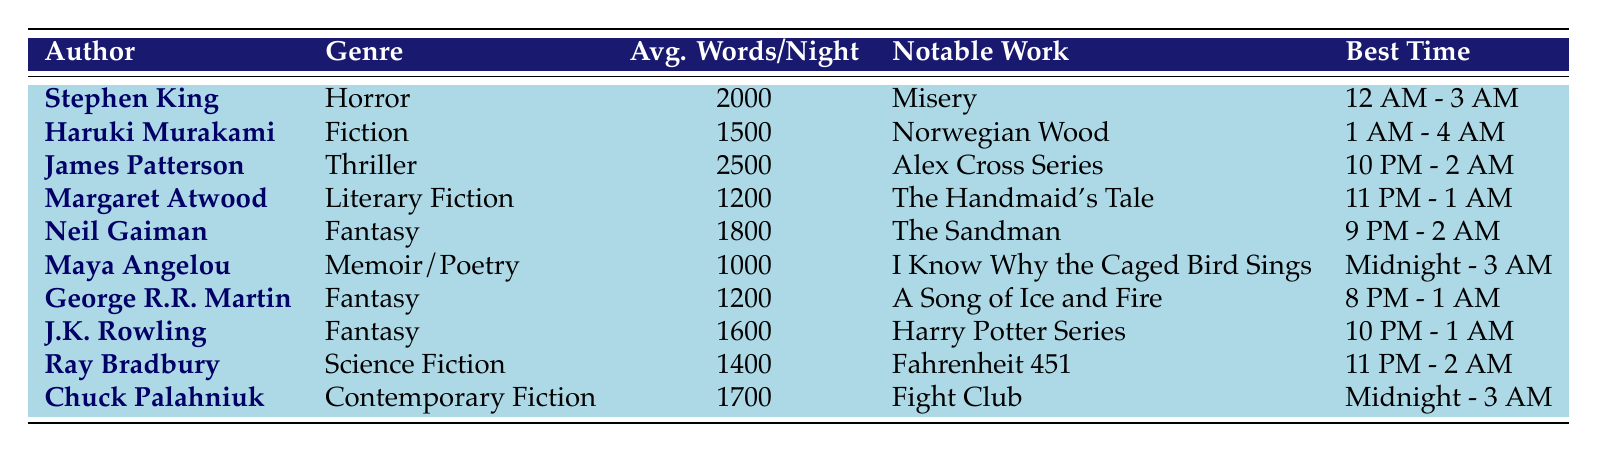What is the average number of words written per night by Stephen King? The table states that Stephen King has an average of 2000 words written per night.
Answer: 2000 Which author wrote "The Handmaid's Tale"? The table lists Margaret Atwood as the author of "The Handmaid's Tale".
Answer: Margaret Atwood Who has the highest average words written per night? By comparing the values in the average words column, James Patterson has the highest average with 2500 words written per night.
Answer: James Patterson What is the best time to write for J.K. Rowling? J.K. Rowling's best time to write is listed as 10 PM - 1 AM in the table.
Answer: 10 PM - 1 AM Is Neil Gaiman's notable nighttime work "Fahrenheit 451"? According to the table, Neil Gaiman's notable work is "The Sandman", not "Fahrenheit 451", which is attributed to Ray Bradbury.
Answer: No How many authors have an average of 1400 words written per night or more? The authors with 1400 words or more are James Patterson, Stephen King, Neil Gaiman, Chuck Palahniuk, and J.K. Rowling. There are 5 such authors in total.
Answer: 5 What is the total number of words written per night by Maya Angelou and George R.R. Martin combined? Maya Angelou writes 1000 words per night and George R.R. Martin writes 1200 words per night. Adding these together gives 1000 + 1200 = 2200.
Answer: 2200 Which genre has the most authors listed in the table? By looking at the genres, Fantasy appears three times (Neil Gaiman, George R.R. Martin, J.K. Rowling), more than any other genre.
Answer: Fantasy What is the average number of words written by authors who write during midnight hours? The authors who write between midnight and 3 AM are Stephen King, Maya Angelou, and Chuck Palahniuk. Their average words are (2000 + 1000 + 1700) / 3 = 1550.
Answer: 1550 Which author has a writing window that begins before midnight? Authors like Neil Gaiman, James Patterson, and J.K. Rowling have writing windows starting before midnight according to the best time to write.
Answer: Neil Gaiman, James Patterson, J.K. Rowling 